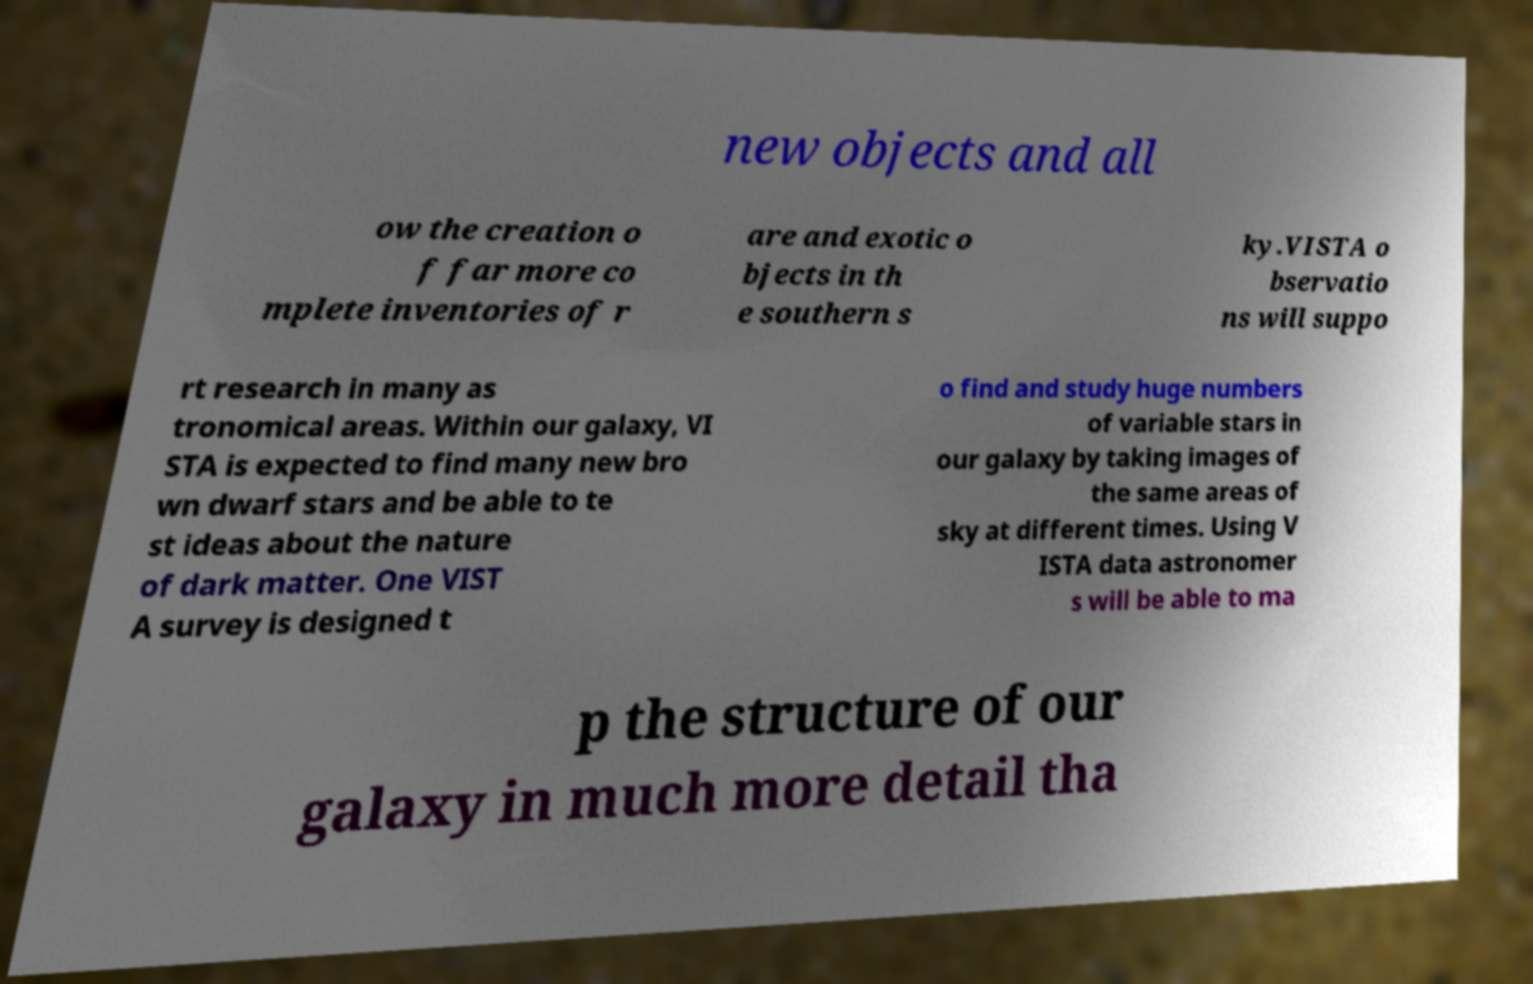Can you accurately transcribe the text from the provided image for me? new objects and all ow the creation o f far more co mplete inventories of r are and exotic o bjects in th e southern s ky.VISTA o bservatio ns will suppo rt research in many as tronomical areas. Within our galaxy, VI STA is expected to find many new bro wn dwarf stars and be able to te st ideas about the nature of dark matter. One VIST A survey is designed t o find and study huge numbers of variable stars in our galaxy by taking images of the same areas of sky at different times. Using V ISTA data astronomer s will be able to ma p the structure of our galaxy in much more detail tha 